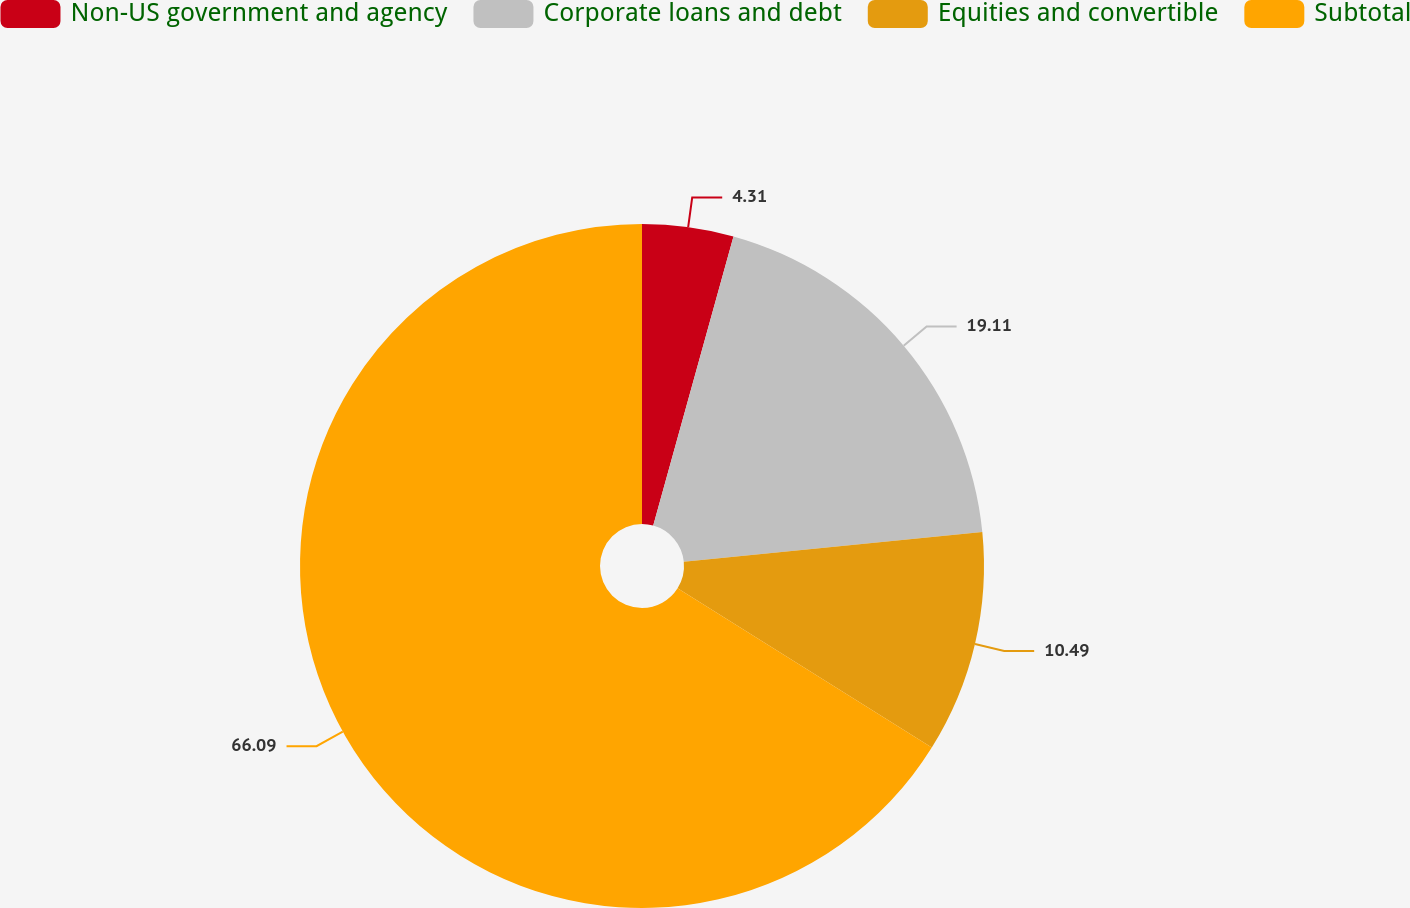Convert chart. <chart><loc_0><loc_0><loc_500><loc_500><pie_chart><fcel>Non-US government and agency<fcel>Corporate loans and debt<fcel>Equities and convertible<fcel>Subtotal<nl><fcel>4.31%<fcel>19.11%<fcel>10.49%<fcel>66.09%<nl></chart> 